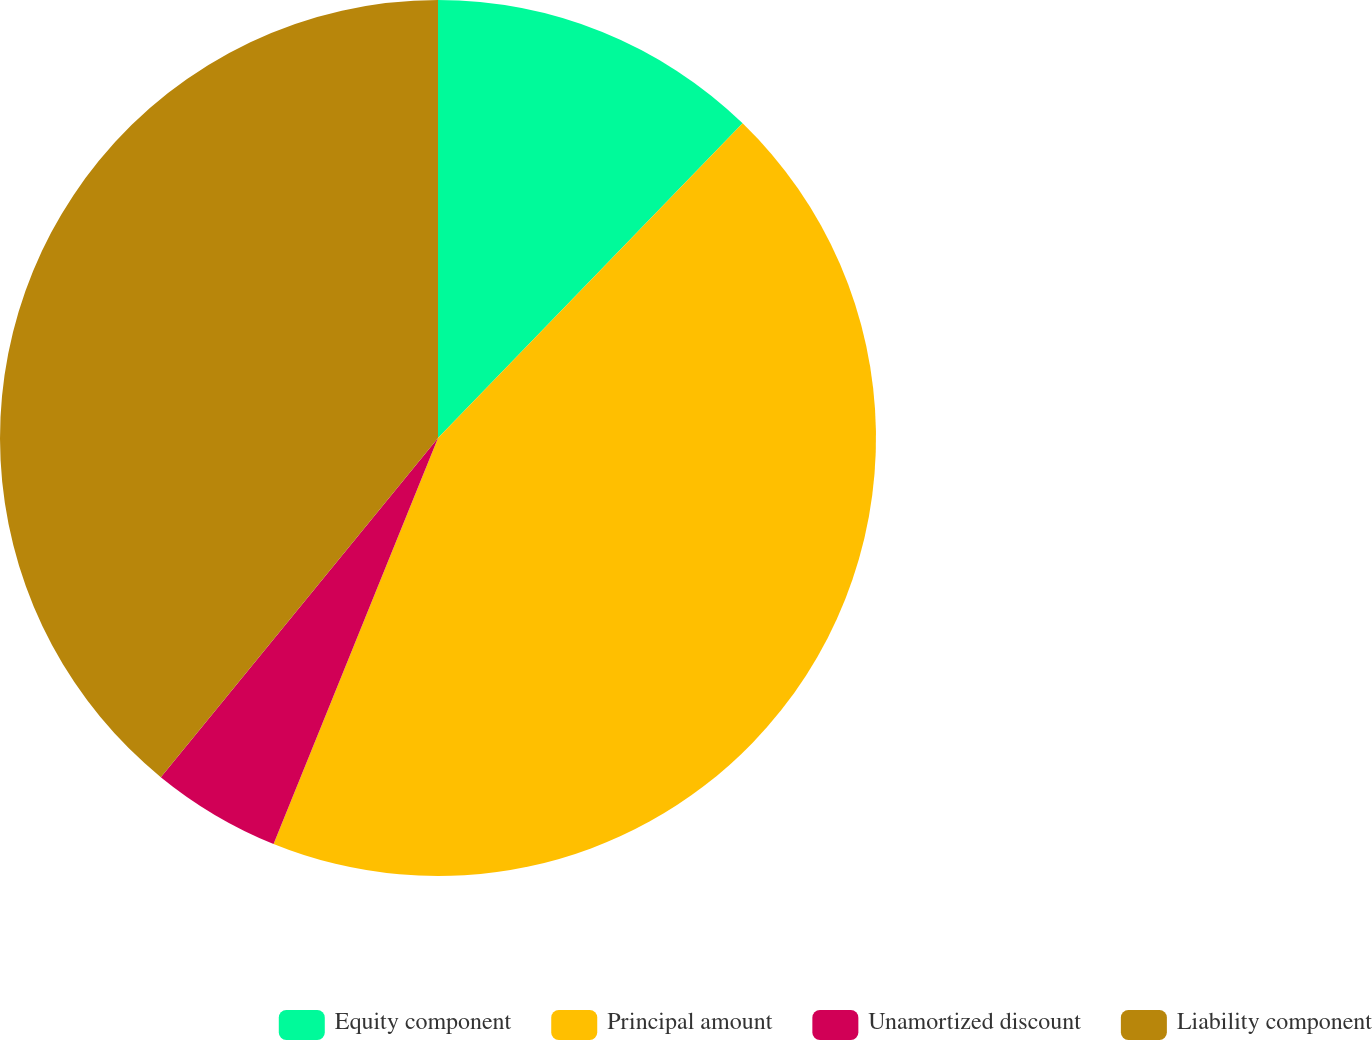<chart> <loc_0><loc_0><loc_500><loc_500><pie_chart><fcel>Equity component<fcel>Principal amount<fcel>Unamortized discount<fcel>Liability component<nl><fcel>12.24%<fcel>43.88%<fcel>4.78%<fcel>39.09%<nl></chart> 